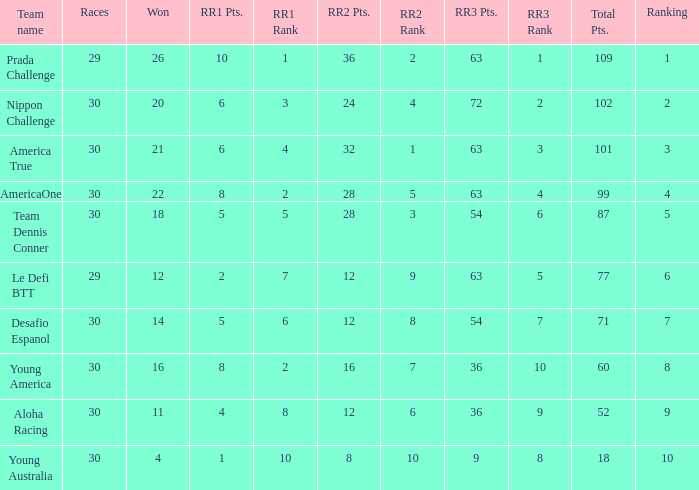Name the total number of rr2 pts for won being 11 1.0. 